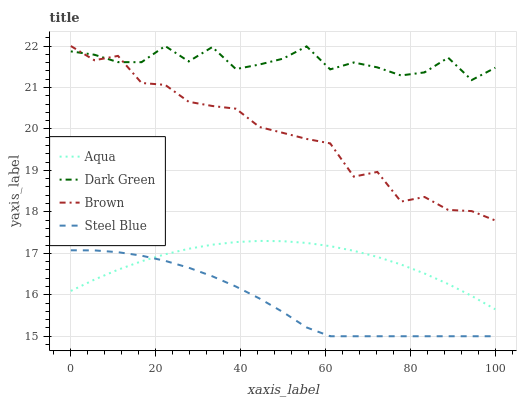Does Steel Blue have the minimum area under the curve?
Answer yes or no. Yes. Does Dark Green have the maximum area under the curve?
Answer yes or no. Yes. Does Aqua have the minimum area under the curve?
Answer yes or no. No. Does Aqua have the maximum area under the curve?
Answer yes or no. No. Is Aqua the smoothest?
Answer yes or no. Yes. Is Dark Green the roughest?
Answer yes or no. Yes. Is Steel Blue the smoothest?
Answer yes or no. No. Is Steel Blue the roughest?
Answer yes or no. No. Does Steel Blue have the lowest value?
Answer yes or no. Yes. Does Aqua have the lowest value?
Answer yes or no. No. Does Dark Green have the highest value?
Answer yes or no. Yes. Does Aqua have the highest value?
Answer yes or no. No. Is Aqua less than Dark Green?
Answer yes or no. Yes. Is Dark Green greater than Aqua?
Answer yes or no. Yes. Does Steel Blue intersect Aqua?
Answer yes or no. Yes. Is Steel Blue less than Aqua?
Answer yes or no. No. Is Steel Blue greater than Aqua?
Answer yes or no. No. Does Aqua intersect Dark Green?
Answer yes or no. No. 